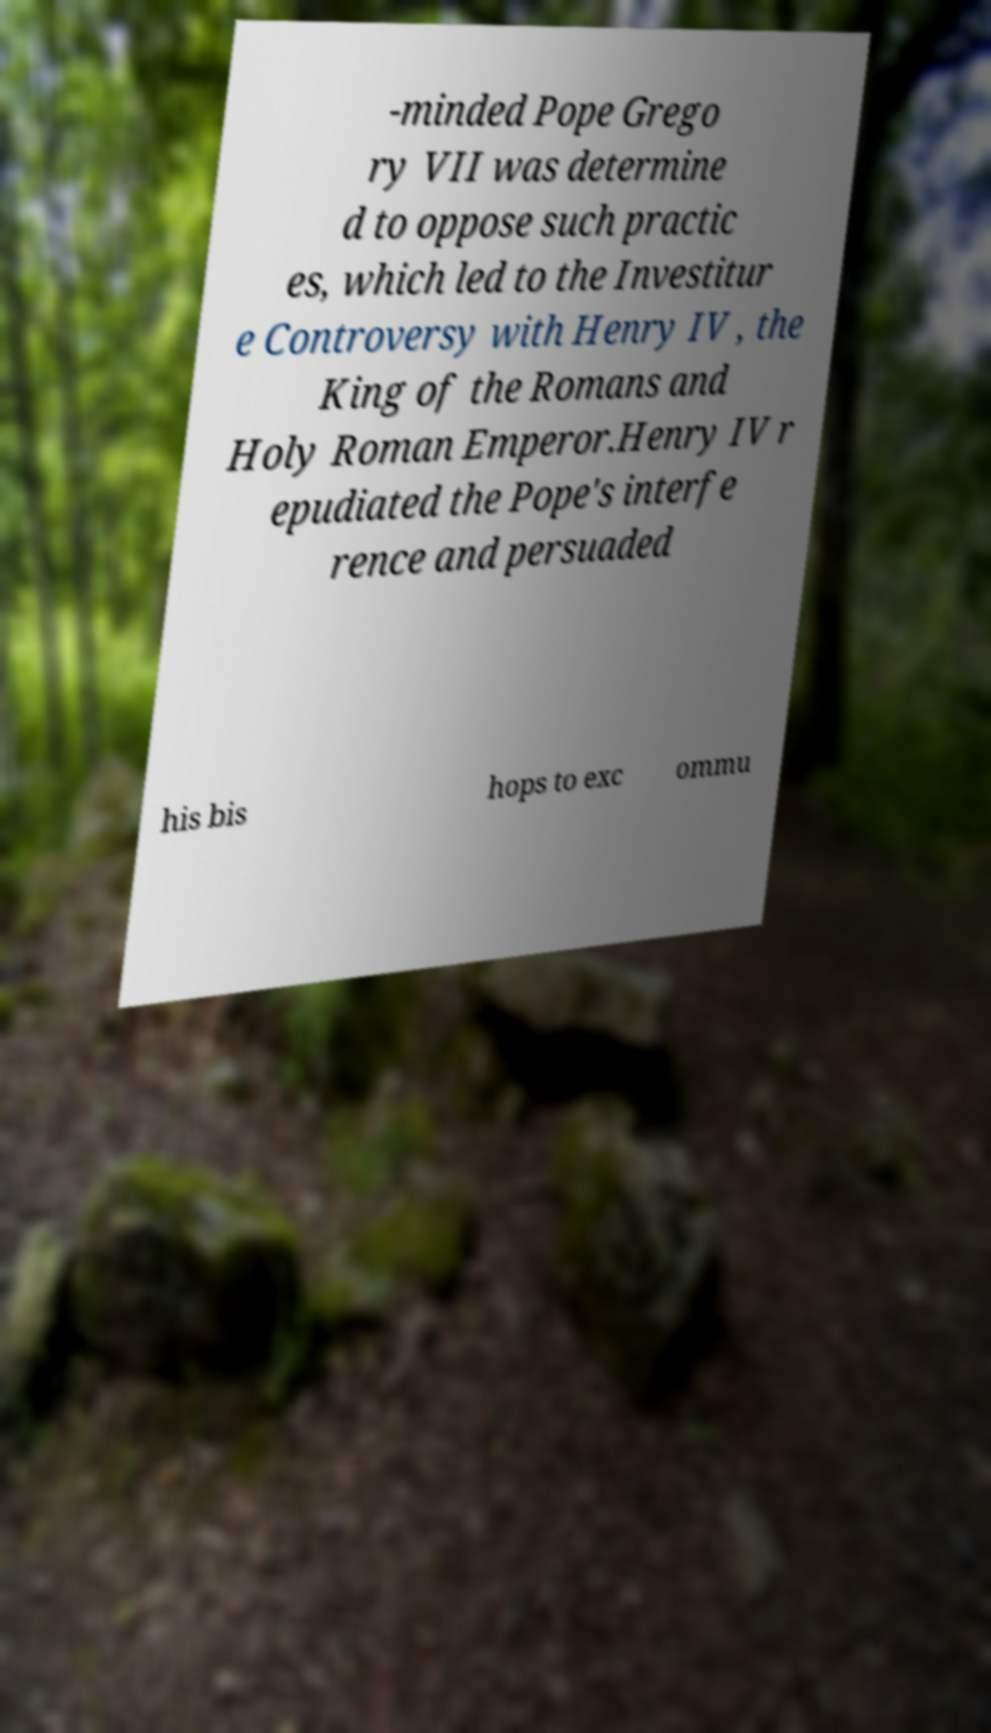There's text embedded in this image that I need extracted. Can you transcribe it verbatim? -minded Pope Grego ry VII was determine d to oppose such practic es, which led to the Investitur e Controversy with Henry IV , the King of the Romans and Holy Roman Emperor.Henry IV r epudiated the Pope's interfe rence and persuaded his bis hops to exc ommu 